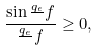Convert formula to latex. <formula><loc_0><loc_0><loc_500><loc_500>\frac { \sin \frac { q _ { e } } { } f } { \frac { q _ { e } } { } f } \geq 0 ,</formula> 